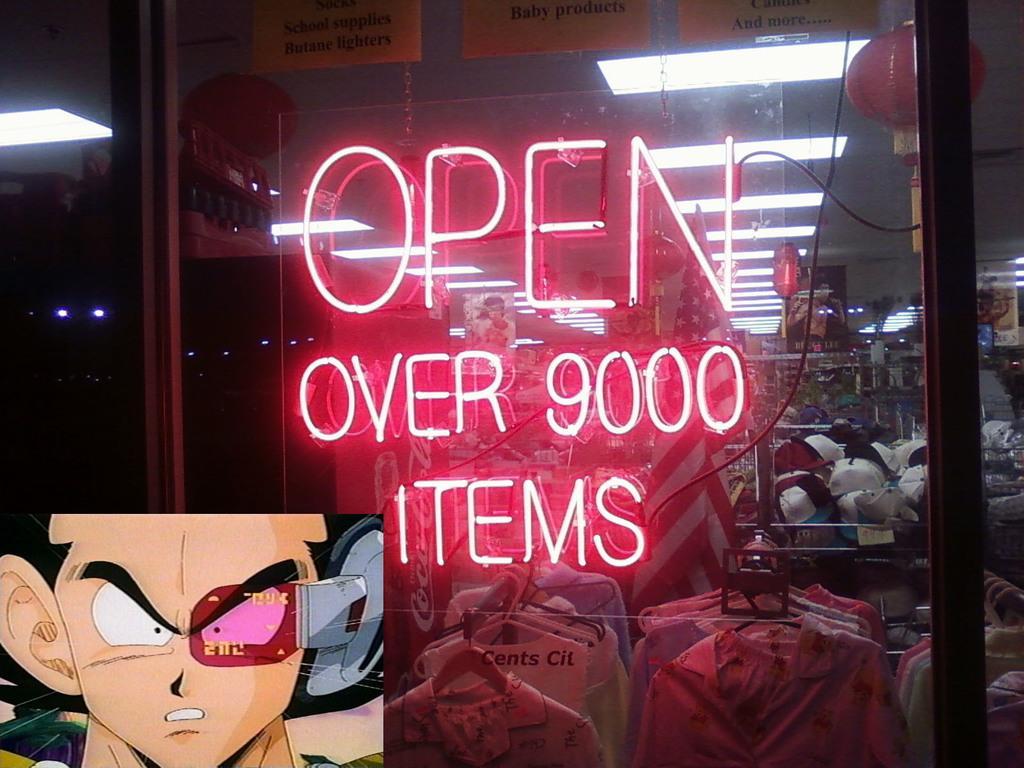Can you describe this image briefly? In this picture I can see something is written in front and on the bottom left corner of this picture I can see a cartoon character. In the background I can see the lights, caps, number of clothes and other things and I see that it is dark on the left side of this image. On the top of this picture I can see the papers on which there is something written. 